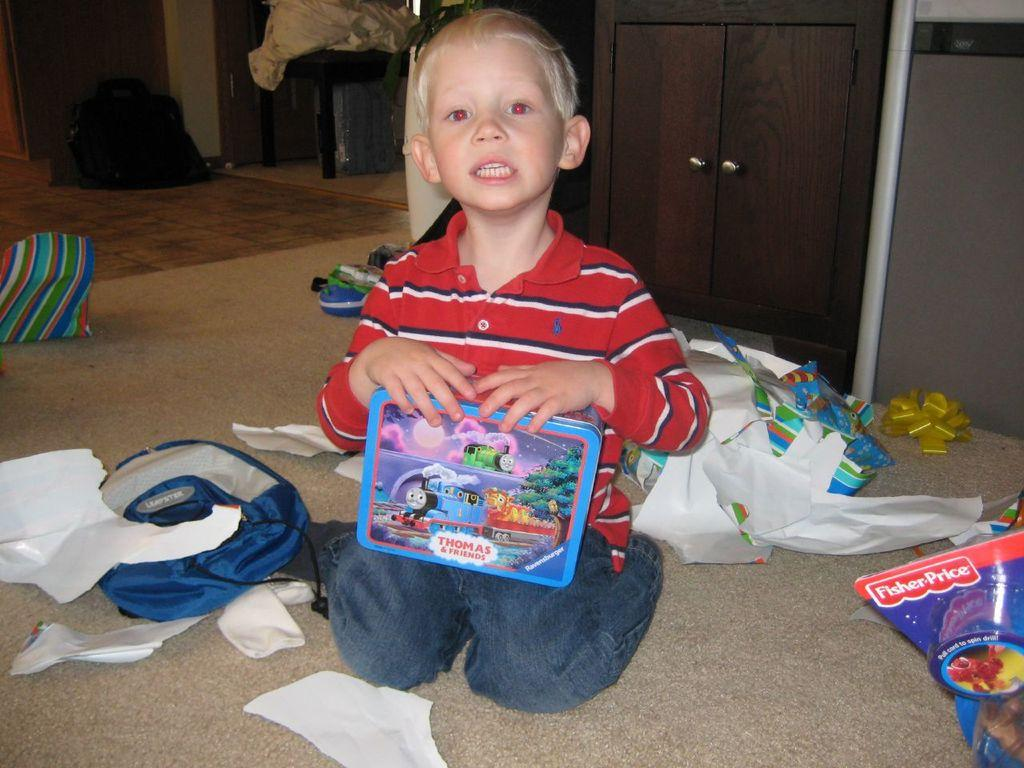What is the kid in the image doing? The kid is sitting in the image. What is the kid holding? The kid is holding a box. What can be seen on the floor in the image? There are papers, bags, and other objects on the floor. What is visible in the background of the image? There is a cupboard and a wall in the background. What type of coal can be seen being used to build the arm in the image? There is no coal or building of an arm present in the image. 